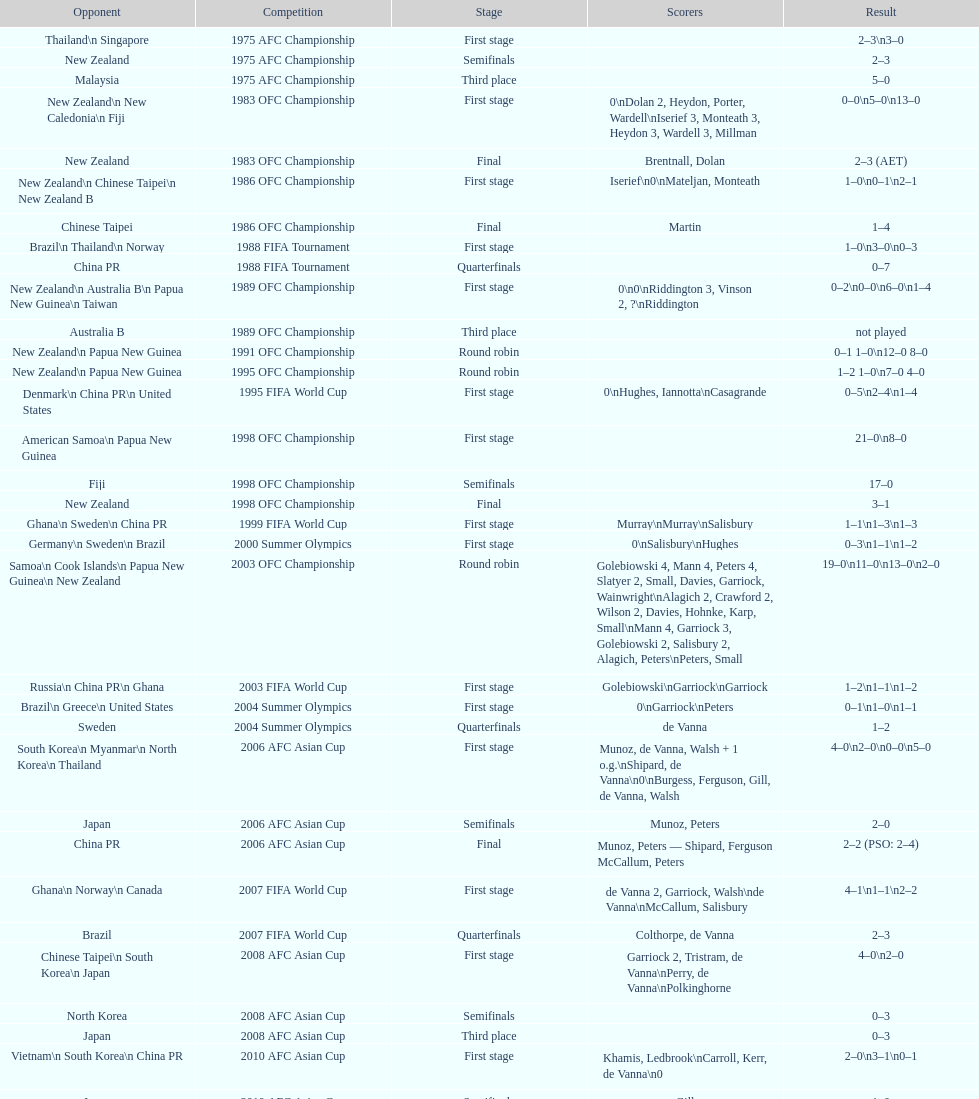How many points were scored in the final round of the 2012 summer olympics afc qualification? 12. 